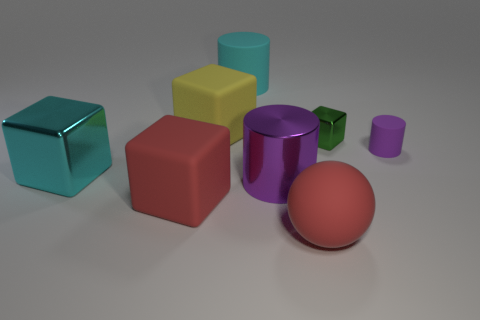Is the number of large cyan objects behind the big cyan metallic thing the same as the number of tiny cyan matte cylinders?
Provide a short and direct response. No. There is a tiny green object behind the rubber cylinder that is right of the large rubber sphere; are there any red rubber objects behind it?
Provide a succinct answer. No. What is the red block made of?
Ensure brevity in your answer.  Rubber. How many other things are the same shape as the large purple metal object?
Provide a short and direct response. 2. Is the shape of the tiny purple matte object the same as the yellow thing?
Your response must be concise. No. What number of objects are large shiny things on the right side of the cyan cylinder or purple cylinders that are to the left of the small metallic block?
Your answer should be compact. 1. How many things are either small green metal objects or big blue balls?
Your response must be concise. 1. There is a big cyan object that is behind the big cyan cube; what number of small shiny objects are to the left of it?
Offer a terse response. 0. How many other objects are the same size as the red matte block?
Offer a terse response. 5. The block that is the same color as the large ball is what size?
Ensure brevity in your answer.  Large. 